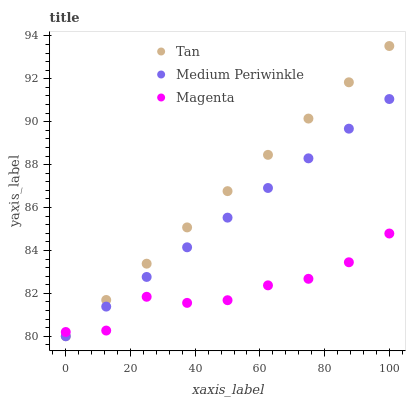Does Magenta have the minimum area under the curve?
Answer yes or no. Yes. Does Tan have the maximum area under the curve?
Answer yes or no. Yes. Does Medium Periwinkle have the minimum area under the curve?
Answer yes or no. No. Does Medium Periwinkle have the maximum area under the curve?
Answer yes or no. No. Is Tan the smoothest?
Answer yes or no. Yes. Is Magenta the roughest?
Answer yes or no. Yes. Is Medium Periwinkle the smoothest?
Answer yes or no. No. Is Medium Periwinkle the roughest?
Answer yes or no. No. Does Tan have the lowest value?
Answer yes or no. Yes. Does Magenta have the lowest value?
Answer yes or no. No. Does Tan have the highest value?
Answer yes or no. Yes. Does Medium Periwinkle have the highest value?
Answer yes or no. No. Does Tan intersect Magenta?
Answer yes or no. Yes. Is Tan less than Magenta?
Answer yes or no. No. Is Tan greater than Magenta?
Answer yes or no. No. 